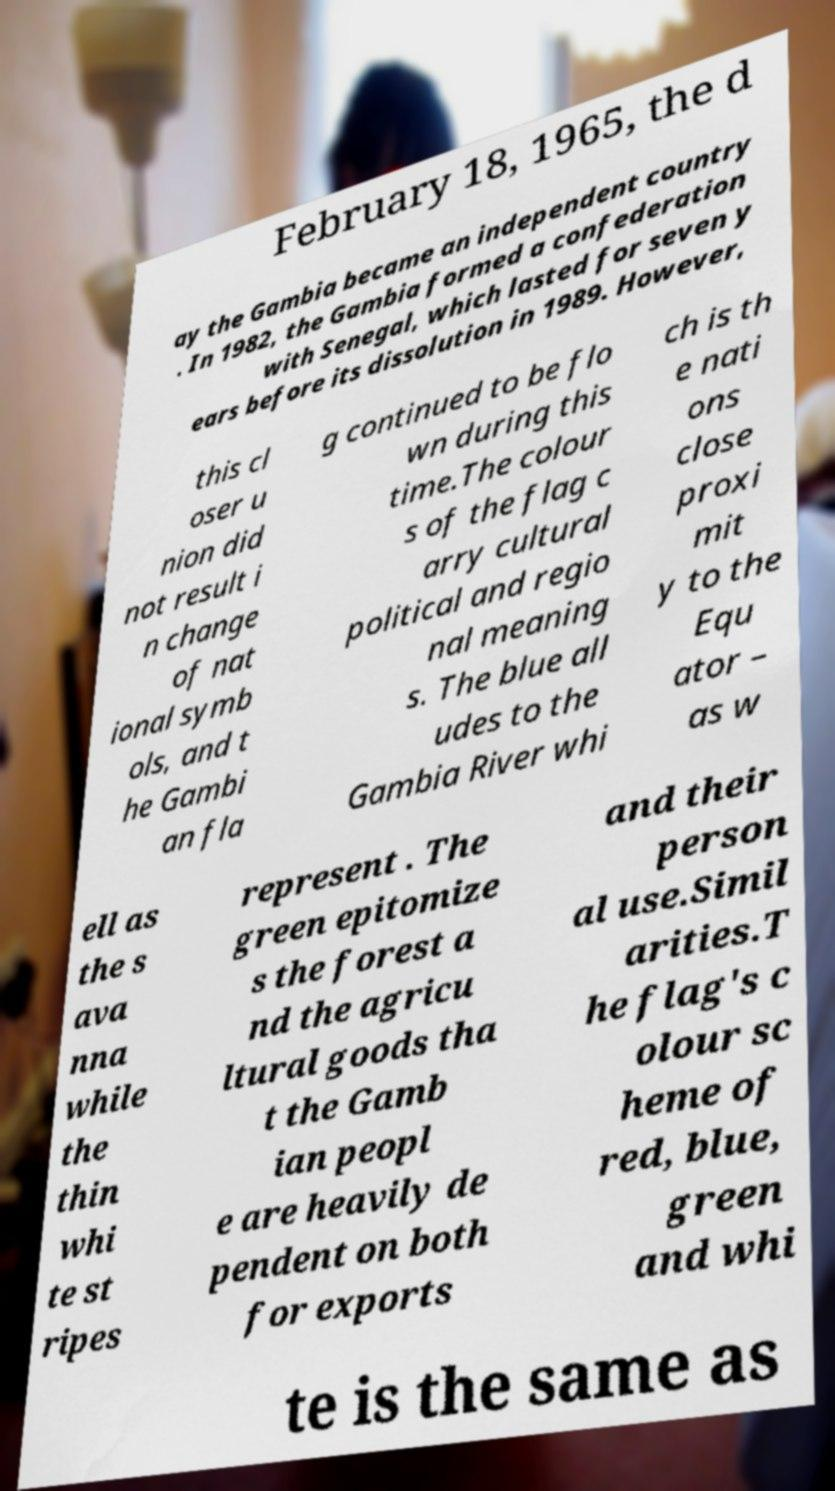Can you accurately transcribe the text from the provided image for me? February 18, 1965, the d ay the Gambia became an independent country . In 1982, the Gambia formed a confederation with Senegal, which lasted for seven y ears before its dissolution in 1989. However, this cl oser u nion did not result i n change of nat ional symb ols, and t he Gambi an fla g continued to be flo wn during this time.The colour s of the flag c arry cultural political and regio nal meaning s. The blue all udes to the Gambia River whi ch is th e nati ons close proxi mit y to the Equ ator – as w ell as the s ava nna while the thin whi te st ripes represent . The green epitomize s the forest a nd the agricu ltural goods tha t the Gamb ian peopl e are heavily de pendent on both for exports and their person al use.Simil arities.T he flag's c olour sc heme of red, blue, green and whi te is the same as 